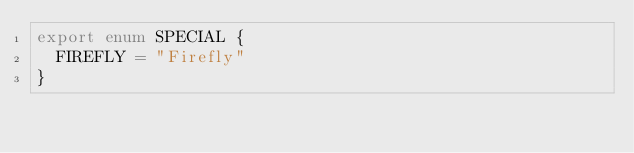Convert code to text. <code><loc_0><loc_0><loc_500><loc_500><_TypeScript_>export enum SPECIAL {
  FIREFLY = "Firefly"
}
</code> 